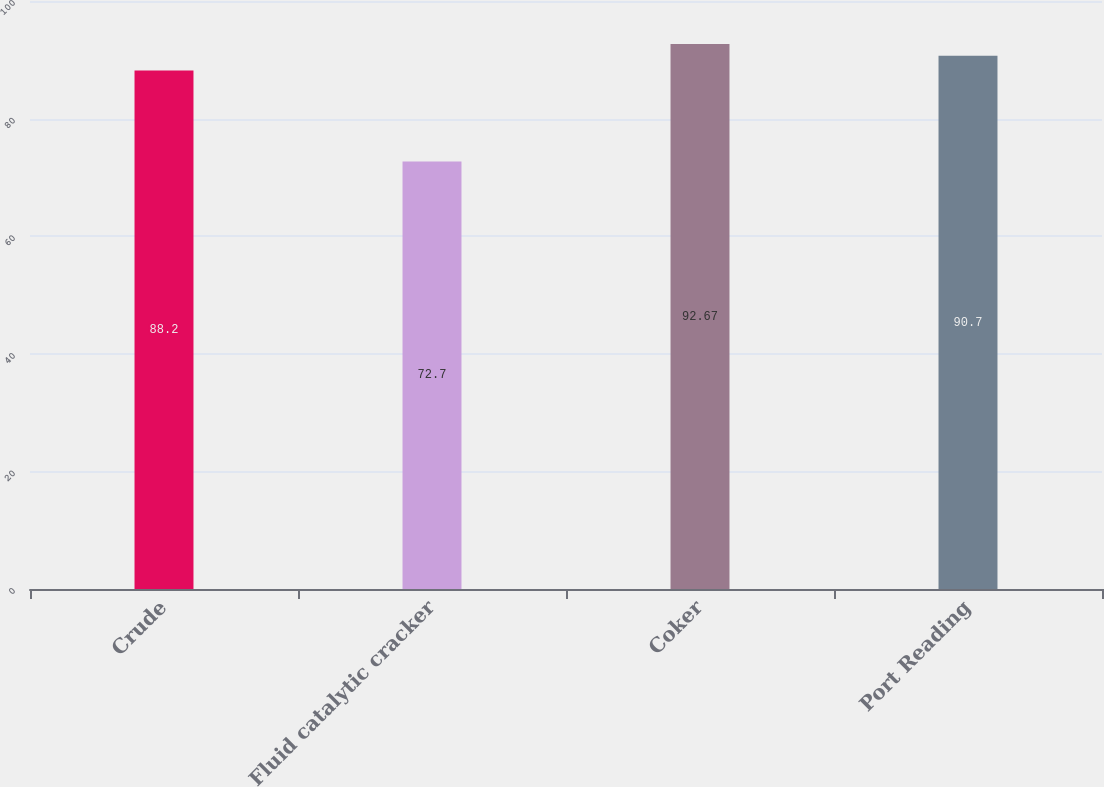Convert chart to OTSL. <chart><loc_0><loc_0><loc_500><loc_500><bar_chart><fcel>Crude<fcel>Fluid catalytic cracker<fcel>Coker<fcel>Port Reading<nl><fcel>88.2<fcel>72.7<fcel>92.67<fcel>90.7<nl></chart> 